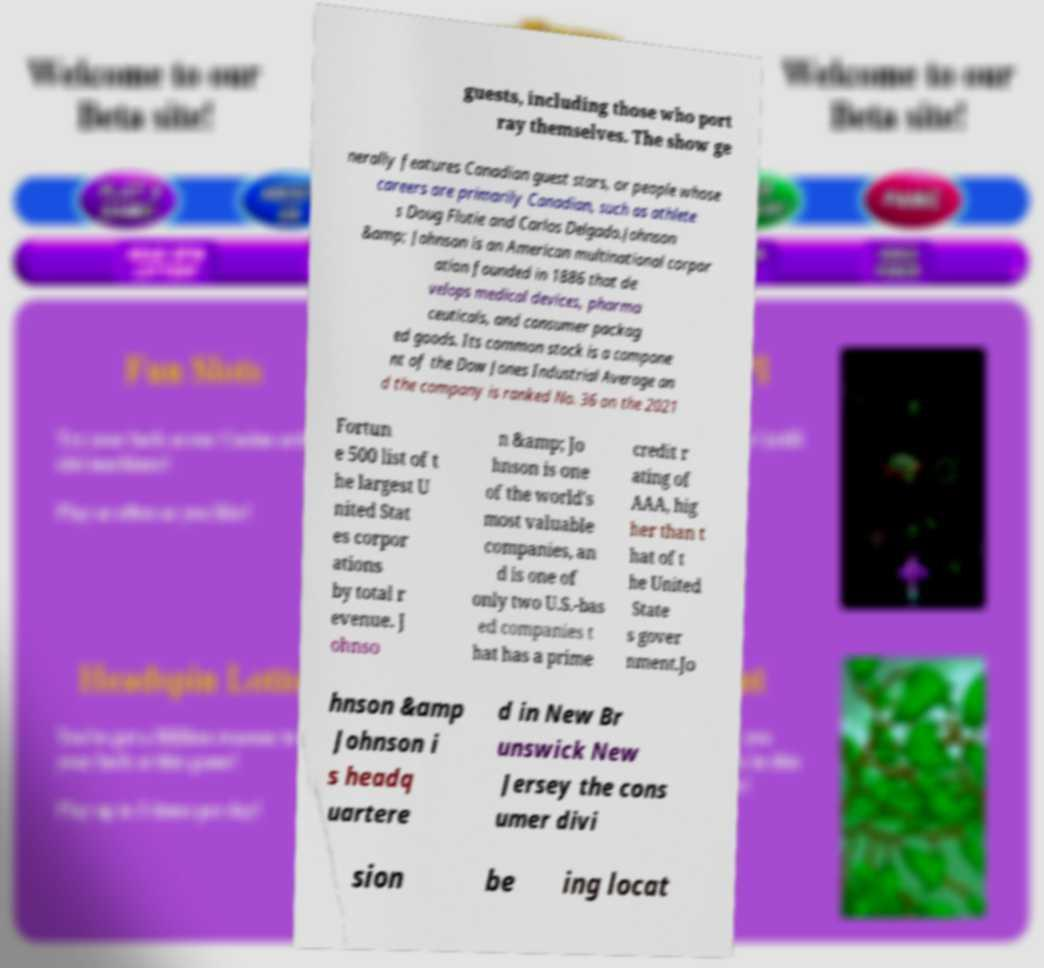There's text embedded in this image that I need extracted. Can you transcribe it verbatim? guests, including those who port ray themselves. The show ge nerally features Canadian guest stars, or people whose careers are primarily Canadian, such as athlete s Doug Flutie and Carlos Delgado.Johnson &amp; Johnson is an American multinational corpor ation founded in 1886 that de velops medical devices, pharma ceuticals, and consumer packag ed goods. Its common stock is a compone nt of the Dow Jones Industrial Average an d the company is ranked No. 36 on the 2021 Fortun e 500 list of t he largest U nited Stat es corpor ations by total r evenue. J ohnso n &amp; Jo hnson is one of the world's most valuable companies, an d is one of only two U.S.-bas ed companies t hat has a prime credit r ating of AAA, hig her than t hat of t he United State s gover nment.Jo hnson &amp Johnson i s headq uartere d in New Br unswick New Jersey the cons umer divi sion be ing locat 